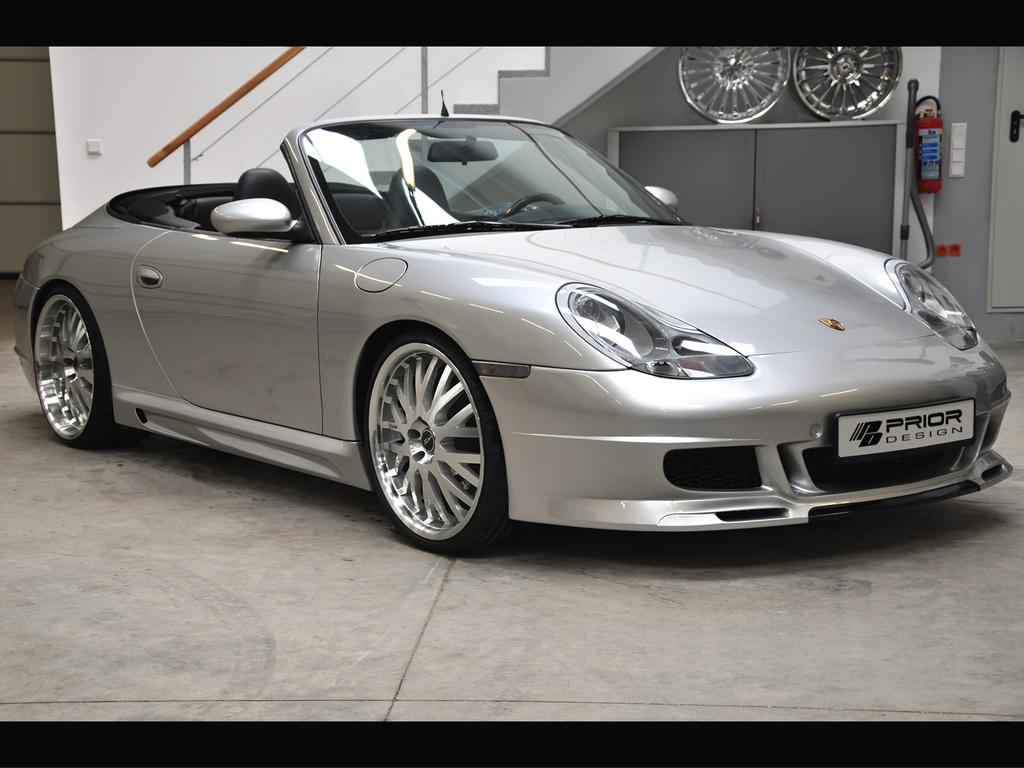What is the main subject of the image? There is a car in the image. Where is the car located in relation to other objects? The car is in front of a wall. What can be seen at the top of the image? There is a staircase and an extinguisher visible in the top right of the image. What part of the car can be seen in the image? The wheels of the car are visible in the top right of the image. What type of jam is being spread on the potato in the image? There is no jam or potato present in the image; it features a car in front of a wall with a staircase, an extinguisher, and visible wheels. 